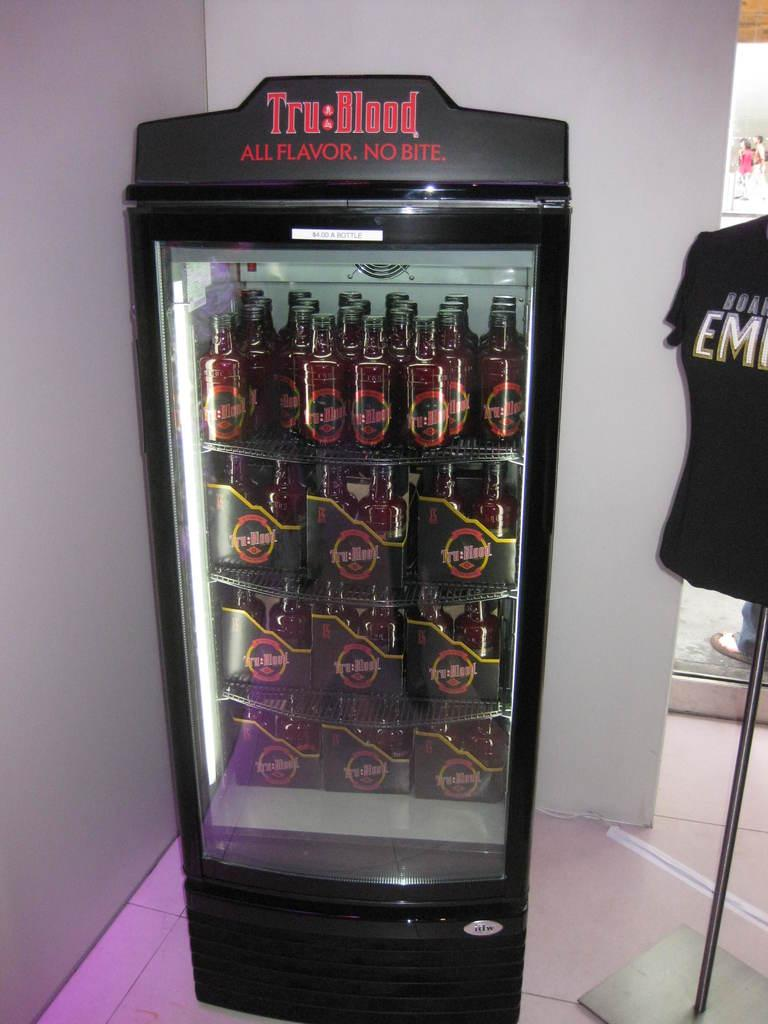<image>
Offer a succinct explanation of the picture presented. Tru Blood freezer with many bottles of Tru Blood inside. 